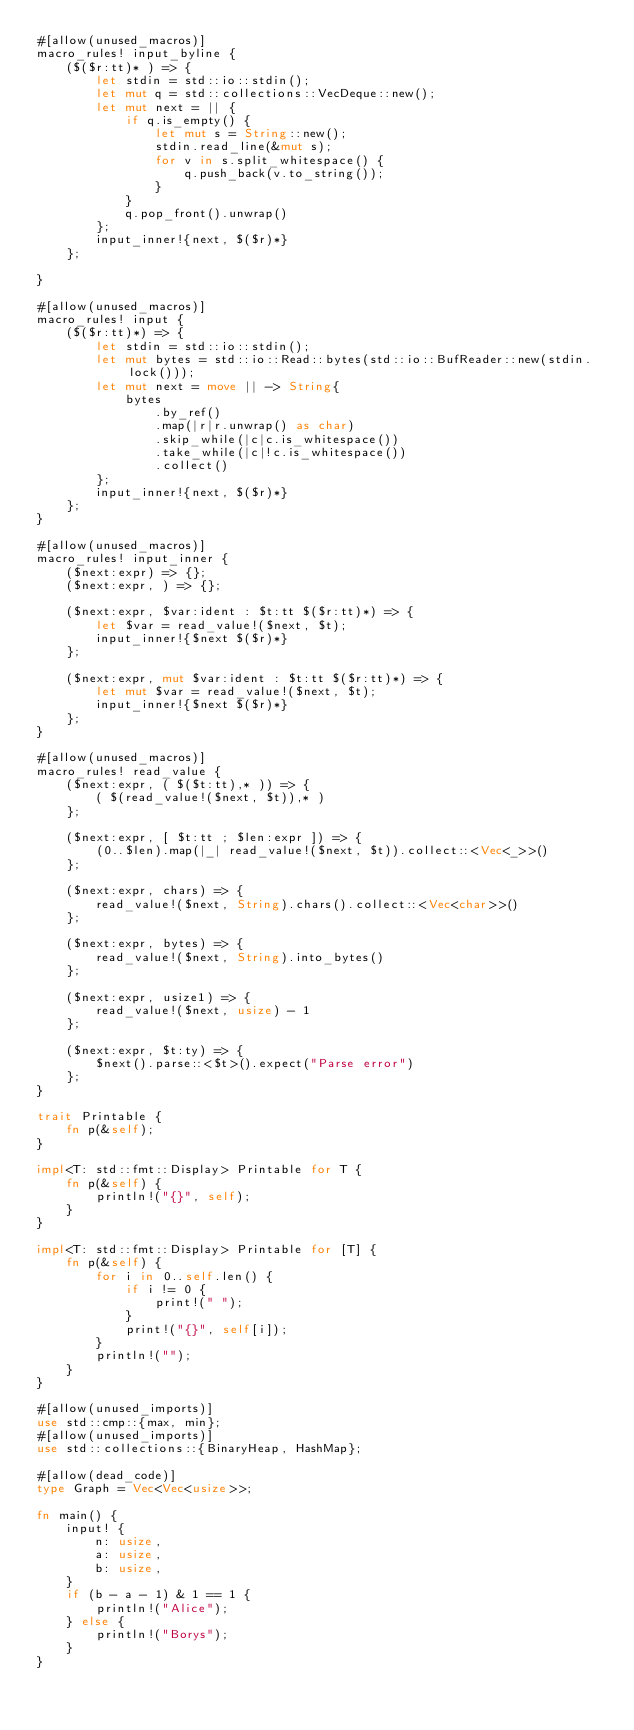Convert code to text. <code><loc_0><loc_0><loc_500><loc_500><_Rust_>#[allow(unused_macros)]
macro_rules! input_byline {
    ($($r:tt)* ) => {
        let stdin = std::io::stdin();
        let mut q = std::collections::VecDeque::new();
        let mut next = || {
            if q.is_empty() {
                let mut s = String::new();
                stdin.read_line(&mut s);
                for v in s.split_whitespace() {
                    q.push_back(v.to_string());
                }
            }
            q.pop_front().unwrap()
        };
        input_inner!{next, $($r)*}
    };

}

#[allow(unused_macros)]
macro_rules! input {
    ($($r:tt)*) => {
        let stdin = std::io::stdin();
        let mut bytes = std::io::Read::bytes(std::io::BufReader::new(stdin.lock()));
        let mut next = move || -> String{
            bytes
                .by_ref()
                .map(|r|r.unwrap() as char)
                .skip_while(|c|c.is_whitespace())
                .take_while(|c|!c.is_whitespace())
                .collect()
        };
        input_inner!{next, $($r)*}
    };
}

#[allow(unused_macros)]
macro_rules! input_inner {
    ($next:expr) => {};
    ($next:expr, ) => {};

    ($next:expr, $var:ident : $t:tt $($r:tt)*) => {
        let $var = read_value!($next, $t);
        input_inner!{$next $($r)*}
    };

    ($next:expr, mut $var:ident : $t:tt $($r:tt)*) => {
        let mut $var = read_value!($next, $t);
        input_inner!{$next $($r)*}
    };
}

#[allow(unused_macros)]
macro_rules! read_value {
    ($next:expr, ( $($t:tt),* )) => {
        ( $(read_value!($next, $t)),* )
    };

    ($next:expr, [ $t:tt ; $len:expr ]) => {
        (0..$len).map(|_| read_value!($next, $t)).collect::<Vec<_>>()
    };

    ($next:expr, chars) => {
        read_value!($next, String).chars().collect::<Vec<char>>()
    };

    ($next:expr, bytes) => {
        read_value!($next, String).into_bytes()
    };

    ($next:expr, usize1) => {
        read_value!($next, usize) - 1
    };

    ($next:expr, $t:ty) => {
        $next().parse::<$t>().expect("Parse error")
    };
}

trait Printable {
    fn p(&self);
}

impl<T: std::fmt::Display> Printable for T {
    fn p(&self) {
        println!("{}", self);
    }
}

impl<T: std::fmt::Display> Printable for [T] {
    fn p(&self) {
        for i in 0..self.len() {
            if i != 0 {
                print!(" ");
            }
            print!("{}", self[i]);
        }
        println!("");
    }
}

#[allow(unused_imports)]
use std::cmp::{max, min};
#[allow(unused_imports)]
use std::collections::{BinaryHeap, HashMap};

#[allow(dead_code)]
type Graph = Vec<Vec<usize>>;

fn main() {
    input! {
        n: usize,
        a: usize,
        b: usize,
    }
    if (b - a - 1) & 1 == 1 {
        println!("Alice");
    } else {
        println!("Borys");
    }
}
</code> 